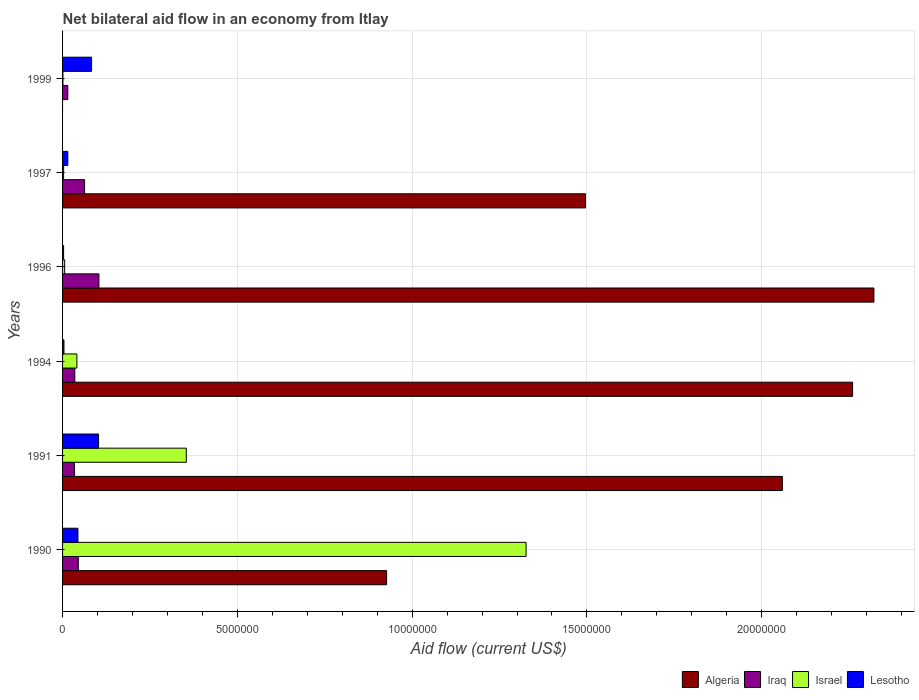How many groups of bars are there?
Your answer should be compact. 6. Are the number of bars per tick equal to the number of legend labels?
Keep it short and to the point. No. Are the number of bars on each tick of the Y-axis equal?
Ensure brevity in your answer.  No. How many bars are there on the 4th tick from the top?
Make the answer very short. 4. What is the label of the 5th group of bars from the top?
Your response must be concise. 1991. In how many cases, is the number of bars for a given year not equal to the number of legend labels?
Your response must be concise. 1. What is the net bilateral aid flow in Algeria in 1994?
Make the answer very short. 2.26e+07. Across all years, what is the maximum net bilateral aid flow in Israel?
Your answer should be very brief. 1.33e+07. Across all years, what is the minimum net bilateral aid flow in Algeria?
Keep it short and to the point. 0. What is the total net bilateral aid flow in Algeria in the graph?
Provide a succinct answer. 9.06e+07. What is the difference between the net bilateral aid flow in Iraq in 1991 and that in 1996?
Ensure brevity in your answer.  -7.00e+05. What is the average net bilateral aid flow in Algeria per year?
Your answer should be very brief. 1.51e+07. In the year 1999, what is the difference between the net bilateral aid flow in Israel and net bilateral aid flow in Lesotho?
Ensure brevity in your answer.  -8.20e+05. In how many years, is the net bilateral aid flow in Lesotho greater than 17000000 US$?
Make the answer very short. 0. What is the ratio of the net bilateral aid flow in Lesotho in 1994 to that in 1997?
Ensure brevity in your answer.  0.27. Is the difference between the net bilateral aid flow in Israel in 1990 and 1999 greater than the difference between the net bilateral aid flow in Lesotho in 1990 and 1999?
Ensure brevity in your answer.  Yes. What is the difference between the highest and the second highest net bilateral aid flow in Lesotho?
Provide a succinct answer. 2.00e+05. What is the difference between the highest and the lowest net bilateral aid flow in Israel?
Make the answer very short. 1.32e+07. In how many years, is the net bilateral aid flow in Algeria greater than the average net bilateral aid flow in Algeria taken over all years?
Offer a terse response. 3. Is it the case that in every year, the sum of the net bilateral aid flow in Lesotho and net bilateral aid flow in Israel is greater than the sum of net bilateral aid flow in Algeria and net bilateral aid flow in Iraq?
Offer a terse response. No. How many bars are there?
Provide a short and direct response. 23. How many years are there in the graph?
Keep it short and to the point. 6. Does the graph contain any zero values?
Offer a terse response. Yes. Where does the legend appear in the graph?
Give a very brief answer. Bottom right. How many legend labels are there?
Your answer should be compact. 4. What is the title of the graph?
Your answer should be very brief. Net bilateral aid flow in an economy from Itlay. What is the label or title of the X-axis?
Your response must be concise. Aid flow (current US$). What is the label or title of the Y-axis?
Provide a short and direct response. Years. What is the Aid flow (current US$) in Algeria in 1990?
Provide a short and direct response. 9.27e+06. What is the Aid flow (current US$) in Israel in 1990?
Your answer should be very brief. 1.33e+07. What is the Aid flow (current US$) in Algeria in 1991?
Provide a short and direct response. 2.06e+07. What is the Aid flow (current US$) in Israel in 1991?
Your answer should be very brief. 3.54e+06. What is the Aid flow (current US$) of Lesotho in 1991?
Provide a succinct answer. 1.03e+06. What is the Aid flow (current US$) of Algeria in 1994?
Your response must be concise. 2.26e+07. What is the Aid flow (current US$) of Iraq in 1994?
Offer a very short reply. 3.50e+05. What is the Aid flow (current US$) in Israel in 1994?
Keep it short and to the point. 4.10e+05. What is the Aid flow (current US$) in Lesotho in 1994?
Provide a succinct answer. 4.00e+04. What is the Aid flow (current US$) of Algeria in 1996?
Provide a succinct answer. 2.32e+07. What is the Aid flow (current US$) of Iraq in 1996?
Offer a very short reply. 1.04e+06. What is the Aid flow (current US$) in Israel in 1996?
Keep it short and to the point. 6.00e+04. What is the Aid flow (current US$) in Algeria in 1997?
Offer a very short reply. 1.50e+07. What is the Aid flow (current US$) of Iraq in 1997?
Ensure brevity in your answer.  6.30e+05. What is the Aid flow (current US$) in Israel in 1997?
Keep it short and to the point. 3.00e+04. What is the Aid flow (current US$) in Algeria in 1999?
Offer a terse response. 0. What is the Aid flow (current US$) of Lesotho in 1999?
Offer a terse response. 8.30e+05. Across all years, what is the maximum Aid flow (current US$) in Algeria?
Make the answer very short. 2.32e+07. Across all years, what is the maximum Aid flow (current US$) in Iraq?
Your answer should be very brief. 1.04e+06. Across all years, what is the maximum Aid flow (current US$) of Israel?
Give a very brief answer. 1.33e+07. Across all years, what is the maximum Aid flow (current US$) of Lesotho?
Your answer should be compact. 1.03e+06. Across all years, what is the minimum Aid flow (current US$) in Iraq?
Provide a short and direct response. 1.50e+05. Across all years, what is the minimum Aid flow (current US$) of Israel?
Make the answer very short. 10000. Across all years, what is the minimum Aid flow (current US$) in Lesotho?
Keep it short and to the point. 3.00e+04. What is the total Aid flow (current US$) in Algeria in the graph?
Make the answer very short. 9.06e+07. What is the total Aid flow (current US$) of Iraq in the graph?
Your answer should be very brief. 2.96e+06. What is the total Aid flow (current US$) in Israel in the graph?
Offer a terse response. 1.73e+07. What is the total Aid flow (current US$) of Lesotho in the graph?
Offer a terse response. 2.52e+06. What is the difference between the Aid flow (current US$) of Algeria in 1990 and that in 1991?
Keep it short and to the point. -1.13e+07. What is the difference between the Aid flow (current US$) of Israel in 1990 and that in 1991?
Give a very brief answer. 9.72e+06. What is the difference between the Aid flow (current US$) of Lesotho in 1990 and that in 1991?
Make the answer very short. -5.90e+05. What is the difference between the Aid flow (current US$) of Algeria in 1990 and that in 1994?
Make the answer very short. -1.33e+07. What is the difference between the Aid flow (current US$) of Iraq in 1990 and that in 1994?
Your answer should be very brief. 1.00e+05. What is the difference between the Aid flow (current US$) of Israel in 1990 and that in 1994?
Provide a short and direct response. 1.28e+07. What is the difference between the Aid flow (current US$) of Lesotho in 1990 and that in 1994?
Your answer should be very brief. 4.00e+05. What is the difference between the Aid flow (current US$) in Algeria in 1990 and that in 1996?
Offer a very short reply. -1.39e+07. What is the difference between the Aid flow (current US$) in Iraq in 1990 and that in 1996?
Your answer should be compact. -5.90e+05. What is the difference between the Aid flow (current US$) in Israel in 1990 and that in 1996?
Offer a terse response. 1.32e+07. What is the difference between the Aid flow (current US$) of Algeria in 1990 and that in 1997?
Provide a succinct answer. -5.69e+06. What is the difference between the Aid flow (current US$) of Israel in 1990 and that in 1997?
Offer a very short reply. 1.32e+07. What is the difference between the Aid flow (current US$) in Iraq in 1990 and that in 1999?
Keep it short and to the point. 3.00e+05. What is the difference between the Aid flow (current US$) of Israel in 1990 and that in 1999?
Ensure brevity in your answer.  1.32e+07. What is the difference between the Aid flow (current US$) of Lesotho in 1990 and that in 1999?
Make the answer very short. -3.90e+05. What is the difference between the Aid flow (current US$) in Algeria in 1991 and that in 1994?
Give a very brief answer. -2.01e+06. What is the difference between the Aid flow (current US$) of Israel in 1991 and that in 1994?
Make the answer very short. 3.13e+06. What is the difference between the Aid flow (current US$) of Lesotho in 1991 and that in 1994?
Your answer should be very brief. 9.90e+05. What is the difference between the Aid flow (current US$) in Algeria in 1991 and that in 1996?
Your answer should be compact. -2.62e+06. What is the difference between the Aid flow (current US$) in Iraq in 1991 and that in 1996?
Ensure brevity in your answer.  -7.00e+05. What is the difference between the Aid flow (current US$) in Israel in 1991 and that in 1996?
Your answer should be compact. 3.48e+06. What is the difference between the Aid flow (current US$) of Lesotho in 1991 and that in 1996?
Keep it short and to the point. 1.00e+06. What is the difference between the Aid flow (current US$) in Algeria in 1991 and that in 1997?
Offer a terse response. 5.63e+06. What is the difference between the Aid flow (current US$) in Iraq in 1991 and that in 1997?
Provide a succinct answer. -2.90e+05. What is the difference between the Aid flow (current US$) in Israel in 1991 and that in 1997?
Your answer should be very brief. 3.51e+06. What is the difference between the Aid flow (current US$) of Lesotho in 1991 and that in 1997?
Ensure brevity in your answer.  8.80e+05. What is the difference between the Aid flow (current US$) in Israel in 1991 and that in 1999?
Your answer should be compact. 3.53e+06. What is the difference between the Aid flow (current US$) of Lesotho in 1991 and that in 1999?
Give a very brief answer. 2.00e+05. What is the difference between the Aid flow (current US$) in Algeria in 1994 and that in 1996?
Provide a succinct answer. -6.10e+05. What is the difference between the Aid flow (current US$) in Iraq in 1994 and that in 1996?
Ensure brevity in your answer.  -6.90e+05. What is the difference between the Aid flow (current US$) of Israel in 1994 and that in 1996?
Provide a succinct answer. 3.50e+05. What is the difference between the Aid flow (current US$) of Algeria in 1994 and that in 1997?
Provide a short and direct response. 7.64e+06. What is the difference between the Aid flow (current US$) of Iraq in 1994 and that in 1997?
Ensure brevity in your answer.  -2.80e+05. What is the difference between the Aid flow (current US$) in Lesotho in 1994 and that in 1997?
Offer a very short reply. -1.10e+05. What is the difference between the Aid flow (current US$) of Israel in 1994 and that in 1999?
Ensure brevity in your answer.  4.00e+05. What is the difference between the Aid flow (current US$) of Lesotho in 1994 and that in 1999?
Give a very brief answer. -7.90e+05. What is the difference between the Aid flow (current US$) of Algeria in 1996 and that in 1997?
Offer a very short reply. 8.25e+06. What is the difference between the Aid flow (current US$) of Iraq in 1996 and that in 1997?
Provide a succinct answer. 4.10e+05. What is the difference between the Aid flow (current US$) of Israel in 1996 and that in 1997?
Provide a short and direct response. 3.00e+04. What is the difference between the Aid flow (current US$) in Lesotho in 1996 and that in 1997?
Offer a terse response. -1.20e+05. What is the difference between the Aid flow (current US$) of Iraq in 1996 and that in 1999?
Your answer should be very brief. 8.90e+05. What is the difference between the Aid flow (current US$) of Lesotho in 1996 and that in 1999?
Provide a short and direct response. -8.00e+05. What is the difference between the Aid flow (current US$) in Iraq in 1997 and that in 1999?
Make the answer very short. 4.80e+05. What is the difference between the Aid flow (current US$) of Israel in 1997 and that in 1999?
Ensure brevity in your answer.  2.00e+04. What is the difference between the Aid flow (current US$) in Lesotho in 1997 and that in 1999?
Keep it short and to the point. -6.80e+05. What is the difference between the Aid flow (current US$) in Algeria in 1990 and the Aid flow (current US$) in Iraq in 1991?
Provide a succinct answer. 8.93e+06. What is the difference between the Aid flow (current US$) in Algeria in 1990 and the Aid flow (current US$) in Israel in 1991?
Provide a succinct answer. 5.73e+06. What is the difference between the Aid flow (current US$) of Algeria in 1990 and the Aid flow (current US$) of Lesotho in 1991?
Ensure brevity in your answer.  8.24e+06. What is the difference between the Aid flow (current US$) of Iraq in 1990 and the Aid flow (current US$) of Israel in 1991?
Keep it short and to the point. -3.09e+06. What is the difference between the Aid flow (current US$) in Iraq in 1990 and the Aid flow (current US$) in Lesotho in 1991?
Ensure brevity in your answer.  -5.80e+05. What is the difference between the Aid flow (current US$) in Israel in 1990 and the Aid flow (current US$) in Lesotho in 1991?
Your answer should be compact. 1.22e+07. What is the difference between the Aid flow (current US$) of Algeria in 1990 and the Aid flow (current US$) of Iraq in 1994?
Offer a very short reply. 8.92e+06. What is the difference between the Aid flow (current US$) in Algeria in 1990 and the Aid flow (current US$) in Israel in 1994?
Provide a short and direct response. 8.86e+06. What is the difference between the Aid flow (current US$) in Algeria in 1990 and the Aid flow (current US$) in Lesotho in 1994?
Your response must be concise. 9.23e+06. What is the difference between the Aid flow (current US$) in Iraq in 1990 and the Aid flow (current US$) in Israel in 1994?
Ensure brevity in your answer.  4.00e+04. What is the difference between the Aid flow (current US$) of Israel in 1990 and the Aid flow (current US$) of Lesotho in 1994?
Ensure brevity in your answer.  1.32e+07. What is the difference between the Aid flow (current US$) of Algeria in 1990 and the Aid flow (current US$) of Iraq in 1996?
Provide a short and direct response. 8.23e+06. What is the difference between the Aid flow (current US$) in Algeria in 1990 and the Aid flow (current US$) in Israel in 1996?
Provide a succinct answer. 9.21e+06. What is the difference between the Aid flow (current US$) in Algeria in 1990 and the Aid flow (current US$) in Lesotho in 1996?
Your answer should be compact. 9.24e+06. What is the difference between the Aid flow (current US$) of Iraq in 1990 and the Aid flow (current US$) of Lesotho in 1996?
Provide a succinct answer. 4.20e+05. What is the difference between the Aid flow (current US$) in Israel in 1990 and the Aid flow (current US$) in Lesotho in 1996?
Your response must be concise. 1.32e+07. What is the difference between the Aid flow (current US$) of Algeria in 1990 and the Aid flow (current US$) of Iraq in 1997?
Your response must be concise. 8.64e+06. What is the difference between the Aid flow (current US$) in Algeria in 1990 and the Aid flow (current US$) in Israel in 1997?
Offer a very short reply. 9.24e+06. What is the difference between the Aid flow (current US$) of Algeria in 1990 and the Aid flow (current US$) of Lesotho in 1997?
Offer a very short reply. 9.12e+06. What is the difference between the Aid flow (current US$) in Iraq in 1990 and the Aid flow (current US$) in Israel in 1997?
Your answer should be very brief. 4.20e+05. What is the difference between the Aid flow (current US$) in Israel in 1990 and the Aid flow (current US$) in Lesotho in 1997?
Your answer should be compact. 1.31e+07. What is the difference between the Aid flow (current US$) of Algeria in 1990 and the Aid flow (current US$) of Iraq in 1999?
Provide a short and direct response. 9.12e+06. What is the difference between the Aid flow (current US$) of Algeria in 1990 and the Aid flow (current US$) of Israel in 1999?
Offer a very short reply. 9.26e+06. What is the difference between the Aid flow (current US$) of Algeria in 1990 and the Aid flow (current US$) of Lesotho in 1999?
Offer a very short reply. 8.44e+06. What is the difference between the Aid flow (current US$) of Iraq in 1990 and the Aid flow (current US$) of Israel in 1999?
Give a very brief answer. 4.40e+05. What is the difference between the Aid flow (current US$) of Iraq in 1990 and the Aid flow (current US$) of Lesotho in 1999?
Offer a very short reply. -3.80e+05. What is the difference between the Aid flow (current US$) of Israel in 1990 and the Aid flow (current US$) of Lesotho in 1999?
Ensure brevity in your answer.  1.24e+07. What is the difference between the Aid flow (current US$) in Algeria in 1991 and the Aid flow (current US$) in Iraq in 1994?
Keep it short and to the point. 2.02e+07. What is the difference between the Aid flow (current US$) of Algeria in 1991 and the Aid flow (current US$) of Israel in 1994?
Keep it short and to the point. 2.02e+07. What is the difference between the Aid flow (current US$) in Algeria in 1991 and the Aid flow (current US$) in Lesotho in 1994?
Provide a succinct answer. 2.06e+07. What is the difference between the Aid flow (current US$) in Iraq in 1991 and the Aid flow (current US$) in Israel in 1994?
Offer a very short reply. -7.00e+04. What is the difference between the Aid flow (current US$) of Iraq in 1991 and the Aid flow (current US$) of Lesotho in 1994?
Offer a very short reply. 3.00e+05. What is the difference between the Aid flow (current US$) in Israel in 1991 and the Aid flow (current US$) in Lesotho in 1994?
Offer a very short reply. 3.50e+06. What is the difference between the Aid flow (current US$) of Algeria in 1991 and the Aid flow (current US$) of Iraq in 1996?
Keep it short and to the point. 1.96e+07. What is the difference between the Aid flow (current US$) in Algeria in 1991 and the Aid flow (current US$) in Israel in 1996?
Your answer should be very brief. 2.05e+07. What is the difference between the Aid flow (current US$) in Algeria in 1991 and the Aid flow (current US$) in Lesotho in 1996?
Make the answer very short. 2.06e+07. What is the difference between the Aid flow (current US$) in Israel in 1991 and the Aid flow (current US$) in Lesotho in 1996?
Offer a very short reply. 3.51e+06. What is the difference between the Aid flow (current US$) of Algeria in 1991 and the Aid flow (current US$) of Iraq in 1997?
Ensure brevity in your answer.  2.00e+07. What is the difference between the Aid flow (current US$) of Algeria in 1991 and the Aid flow (current US$) of Israel in 1997?
Your response must be concise. 2.06e+07. What is the difference between the Aid flow (current US$) of Algeria in 1991 and the Aid flow (current US$) of Lesotho in 1997?
Your response must be concise. 2.04e+07. What is the difference between the Aid flow (current US$) in Iraq in 1991 and the Aid flow (current US$) in Israel in 1997?
Provide a short and direct response. 3.10e+05. What is the difference between the Aid flow (current US$) of Iraq in 1991 and the Aid flow (current US$) of Lesotho in 1997?
Offer a terse response. 1.90e+05. What is the difference between the Aid flow (current US$) of Israel in 1991 and the Aid flow (current US$) of Lesotho in 1997?
Ensure brevity in your answer.  3.39e+06. What is the difference between the Aid flow (current US$) of Algeria in 1991 and the Aid flow (current US$) of Iraq in 1999?
Provide a succinct answer. 2.04e+07. What is the difference between the Aid flow (current US$) of Algeria in 1991 and the Aid flow (current US$) of Israel in 1999?
Make the answer very short. 2.06e+07. What is the difference between the Aid flow (current US$) of Algeria in 1991 and the Aid flow (current US$) of Lesotho in 1999?
Make the answer very short. 1.98e+07. What is the difference between the Aid flow (current US$) of Iraq in 1991 and the Aid flow (current US$) of Lesotho in 1999?
Provide a short and direct response. -4.90e+05. What is the difference between the Aid flow (current US$) in Israel in 1991 and the Aid flow (current US$) in Lesotho in 1999?
Provide a short and direct response. 2.71e+06. What is the difference between the Aid flow (current US$) in Algeria in 1994 and the Aid flow (current US$) in Iraq in 1996?
Give a very brief answer. 2.16e+07. What is the difference between the Aid flow (current US$) in Algeria in 1994 and the Aid flow (current US$) in Israel in 1996?
Your answer should be very brief. 2.25e+07. What is the difference between the Aid flow (current US$) in Algeria in 1994 and the Aid flow (current US$) in Lesotho in 1996?
Your response must be concise. 2.26e+07. What is the difference between the Aid flow (current US$) in Iraq in 1994 and the Aid flow (current US$) in Israel in 1996?
Provide a succinct answer. 2.90e+05. What is the difference between the Aid flow (current US$) in Algeria in 1994 and the Aid flow (current US$) in Iraq in 1997?
Keep it short and to the point. 2.20e+07. What is the difference between the Aid flow (current US$) of Algeria in 1994 and the Aid flow (current US$) of Israel in 1997?
Your answer should be very brief. 2.26e+07. What is the difference between the Aid flow (current US$) of Algeria in 1994 and the Aid flow (current US$) of Lesotho in 1997?
Provide a succinct answer. 2.24e+07. What is the difference between the Aid flow (current US$) of Iraq in 1994 and the Aid flow (current US$) of Israel in 1997?
Your answer should be very brief. 3.20e+05. What is the difference between the Aid flow (current US$) of Algeria in 1994 and the Aid flow (current US$) of Iraq in 1999?
Offer a very short reply. 2.24e+07. What is the difference between the Aid flow (current US$) in Algeria in 1994 and the Aid flow (current US$) in Israel in 1999?
Ensure brevity in your answer.  2.26e+07. What is the difference between the Aid flow (current US$) of Algeria in 1994 and the Aid flow (current US$) of Lesotho in 1999?
Give a very brief answer. 2.18e+07. What is the difference between the Aid flow (current US$) of Iraq in 1994 and the Aid flow (current US$) of Israel in 1999?
Keep it short and to the point. 3.40e+05. What is the difference between the Aid flow (current US$) of Iraq in 1994 and the Aid flow (current US$) of Lesotho in 1999?
Make the answer very short. -4.80e+05. What is the difference between the Aid flow (current US$) of Israel in 1994 and the Aid flow (current US$) of Lesotho in 1999?
Ensure brevity in your answer.  -4.20e+05. What is the difference between the Aid flow (current US$) in Algeria in 1996 and the Aid flow (current US$) in Iraq in 1997?
Give a very brief answer. 2.26e+07. What is the difference between the Aid flow (current US$) in Algeria in 1996 and the Aid flow (current US$) in Israel in 1997?
Give a very brief answer. 2.32e+07. What is the difference between the Aid flow (current US$) in Algeria in 1996 and the Aid flow (current US$) in Lesotho in 1997?
Keep it short and to the point. 2.31e+07. What is the difference between the Aid flow (current US$) of Iraq in 1996 and the Aid flow (current US$) of Israel in 1997?
Keep it short and to the point. 1.01e+06. What is the difference between the Aid flow (current US$) of Iraq in 1996 and the Aid flow (current US$) of Lesotho in 1997?
Keep it short and to the point. 8.90e+05. What is the difference between the Aid flow (current US$) of Israel in 1996 and the Aid flow (current US$) of Lesotho in 1997?
Make the answer very short. -9.00e+04. What is the difference between the Aid flow (current US$) in Algeria in 1996 and the Aid flow (current US$) in Iraq in 1999?
Your answer should be compact. 2.31e+07. What is the difference between the Aid flow (current US$) in Algeria in 1996 and the Aid flow (current US$) in Israel in 1999?
Keep it short and to the point. 2.32e+07. What is the difference between the Aid flow (current US$) in Algeria in 1996 and the Aid flow (current US$) in Lesotho in 1999?
Ensure brevity in your answer.  2.24e+07. What is the difference between the Aid flow (current US$) of Iraq in 1996 and the Aid flow (current US$) of Israel in 1999?
Provide a short and direct response. 1.03e+06. What is the difference between the Aid flow (current US$) of Iraq in 1996 and the Aid flow (current US$) of Lesotho in 1999?
Ensure brevity in your answer.  2.10e+05. What is the difference between the Aid flow (current US$) in Israel in 1996 and the Aid flow (current US$) in Lesotho in 1999?
Provide a succinct answer. -7.70e+05. What is the difference between the Aid flow (current US$) in Algeria in 1997 and the Aid flow (current US$) in Iraq in 1999?
Your answer should be compact. 1.48e+07. What is the difference between the Aid flow (current US$) in Algeria in 1997 and the Aid flow (current US$) in Israel in 1999?
Offer a very short reply. 1.50e+07. What is the difference between the Aid flow (current US$) of Algeria in 1997 and the Aid flow (current US$) of Lesotho in 1999?
Ensure brevity in your answer.  1.41e+07. What is the difference between the Aid flow (current US$) of Iraq in 1997 and the Aid flow (current US$) of Israel in 1999?
Make the answer very short. 6.20e+05. What is the difference between the Aid flow (current US$) of Iraq in 1997 and the Aid flow (current US$) of Lesotho in 1999?
Your answer should be compact. -2.00e+05. What is the difference between the Aid flow (current US$) of Israel in 1997 and the Aid flow (current US$) of Lesotho in 1999?
Ensure brevity in your answer.  -8.00e+05. What is the average Aid flow (current US$) in Algeria per year?
Offer a terse response. 1.51e+07. What is the average Aid flow (current US$) in Iraq per year?
Your answer should be very brief. 4.93e+05. What is the average Aid flow (current US$) of Israel per year?
Offer a terse response. 2.88e+06. In the year 1990, what is the difference between the Aid flow (current US$) of Algeria and Aid flow (current US$) of Iraq?
Make the answer very short. 8.82e+06. In the year 1990, what is the difference between the Aid flow (current US$) of Algeria and Aid flow (current US$) of Israel?
Offer a terse response. -3.99e+06. In the year 1990, what is the difference between the Aid flow (current US$) of Algeria and Aid flow (current US$) of Lesotho?
Provide a short and direct response. 8.83e+06. In the year 1990, what is the difference between the Aid flow (current US$) in Iraq and Aid flow (current US$) in Israel?
Your response must be concise. -1.28e+07. In the year 1990, what is the difference between the Aid flow (current US$) in Israel and Aid flow (current US$) in Lesotho?
Your answer should be compact. 1.28e+07. In the year 1991, what is the difference between the Aid flow (current US$) of Algeria and Aid flow (current US$) of Iraq?
Your answer should be compact. 2.02e+07. In the year 1991, what is the difference between the Aid flow (current US$) in Algeria and Aid flow (current US$) in Israel?
Provide a succinct answer. 1.70e+07. In the year 1991, what is the difference between the Aid flow (current US$) in Algeria and Aid flow (current US$) in Lesotho?
Keep it short and to the point. 1.96e+07. In the year 1991, what is the difference between the Aid flow (current US$) in Iraq and Aid flow (current US$) in Israel?
Keep it short and to the point. -3.20e+06. In the year 1991, what is the difference between the Aid flow (current US$) of Iraq and Aid flow (current US$) of Lesotho?
Your answer should be very brief. -6.90e+05. In the year 1991, what is the difference between the Aid flow (current US$) in Israel and Aid flow (current US$) in Lesotho?
Your answer should be compact. 2.51e+06. In the year 1994, what is the difference between the Aid flow (current US$) in Algeria and Aid flow (current US$) in Iraq?
Ensure brevity in your answer.  2.22e+07. In the year 1994, what is the difference between the Aid flow (current US$) in Algeria and Aid flow (current US$) in Israel?
Offer a very short reply. 2.22e+07. In the year 1994, what is the difference between the Aid flow (current US$) of Algeria and Aid flow (current US$) of Lesotho?
Your answer should be very brief. 2.26e+07. In the year 1994, what is the difference between the Aid flow (current US$) of Israel and Aid flow (current US$) of Lesotho?
Provide a short and direct response. 3.70e+05. In the year 1996, what is the difference between the Aid flow (current US$) of Algeria and Aid flow (current US$) of Iraq?
Your answer should be compact. 2.22e+07. In the year 1996, what is the difference between the Aid flow (current US$) in Algeria and Aid flow (current US$) in Israel?
Ensure brevity in your answer.  2.32e+07. In the year 1996, what is the difference between the Aid flow (current US$) of Algeria and Aid flow (current US$) of Lesotho?
Give a very brief answer. 2.32e+07. In the year 1996, what is the difference between the Aid flow (current US$) of Iraq and Aid flow (current US$) of Israel?
Your answer should be compact. 9.80e+05. In the year 1996, what is the difference between the Aid flow (current US$) in Iraq and Aid flow (current US$) in Lesotho?
Provide a succinct answer. 1.01e+06. In the year 1997, what is the difference between the Aid flow (current US$) in Algeria and Aid flow (current US$) in Iraq?
Offer a very short reply. 1.43e+07. In the year 1997, what is the difference between the Aid flow (current US$) in Algeria and Aid flow (current US$) in Israel?
Offer a very short reply. 1.49e+07. In the year 1997, what is the difference between the Aid flow (current US$) in Algeria and Aid flow (current US$) in Lesotho?
Keep it short and to the point. 1.48e+07. In the year 1997, what is the difference between the Aid flow (current US$) of Iraq and Aid flow (current US$) of Israel?
Keep it short and to the point. 6.00e+05. In the year 1997, what is the difference between the Aid flow (current US$) of Iraq and Aid flow (current US$) of Lesotho?
Make the answer very short. 4.80e+05. In the year 1999, what is the difference between the Aid flow (current US$) of Iraq and Aid flow (current US$) of Israel?
Provide a succinct answer. 1.40e+05. In the year 1999, what is the difference between the Aid flow (current US$) in Iraq and Aid flow (current US$) in Lesotho?
Offer a terse response. -6.80e+05. In the year 1999, what is the difference between the Aid flow (current US$) in Israel and Aid flow (current US$) in Lesotho?
Keep it short and to the point. -8.20e+05. What is the ratio of the Aid flow (current US$) of Algeria in 1990 to that in 1991?
Offer a terse response. 0.45. What is the ratio of the Aid flow (current US$) of Iraq in 1990 to that in 1991?
Keep it short and to the point. 1.32. What is the ratio of the Aid flow (current US$) of Israel in 1990 to that in 1991?
Your response must be concise. 3.75. What is the ratio of the Aid flow (current US$) in Lesotho in 1990 to that in 1991?
Keep it short and to the point. 0.43. What is the ratio of the Aid flow (current US$) in Algeria in 1990 to that in 1994?
Provide a short and direct response. 0.41. What is the ratio of the Aid flow (current US$) of Iraq in 1990 to that in 1994?
Offer a very short reply. 1.29. What is the ratio of the Aid flow (current US$) in Israel in 1990 to that in 1994?
Your answer should be compact. 32.34. What is the ratio of the Aid flow (current US$) of Lesotho in 1990 to that in 1994?
Offer a very short reply. 11. What is the ratio of the Aid flow (current US$) in Algeria in 1990 to that in 1996?
Your answer should be compact. 0.4. What is the ratio of the Aid flow (current US$) of Iraq in 1990 to that in 1996?
Provide a short and direct response. 0.43. What is the ratio of the Aid flow (current US$) in Israel in 1990 to that in 1996?
Keep it short and to the point. 221. What is the ratio of the Aid flow (current US$) of Lesotho in 1990 to that in 1996?
Ensure brevity in your answer.  14.67. What is the ratio of the Aid flow (current US$) of Algeria in 1990 to that in 1997?
Give a very brief answer. 0.62. What is the ratio of the Aid flow (current US$) of Israel in 1990 to that in 1997?
Make the answer very short. 442. What is the ratio of the Aid flow (current US$) of Lesotho in 1990 to that in 1997?
Your answer should be very brief. 2.93. What is the ratio of the Aid flow (current US$) of Iraq in 1990 to that in 1999?
Give a very brief answer. 3. What is the ratio of the Aid flow (current US$) in Israel in 1990 to that in 1999?
Offer a very short reply. 1326. What is the ratio of the Aid flow (current US$) of Lesotho in 1990 to that in 1999?
Your answer should be compact. 0.53. What is the ratio of the Aid flow (current US$) of Algeria in 1991 to that in 1994?
Make the answer very short. 0.91. What is the ratio of the Aid flow (current US$) in Iraq in 1991 to that in 1994?
Give a very brief answer. 0.97. What is the ratio of the Aid flow (current US$) of Israel in 1991 to that in 1994?
Your response must be concise. 8.63. What is the ratio of the Aid flow (current US$) in Lesotho in 1991 to that in 1994?
Provide a succinct answer. 25.75. What is the ratio of the Aid flow (current US$) of Algeria in 1991 to that in 1996?
Offer a terse response. 0.89. What is the ratio of the Aid flow (current US$) of Iraq in 1991 to that in 1996?
Your answer should be compact. 0.33. What is the ratio of the Aid flow (current US$) in Lesotho in 1991 to that in 1996?
Your answer should be compact. 34.33. What is the ratio of the Aid flow (current US$) in Algeria in 1991 to that in 1997?
Offer a very short reply. 1.38. What is the ratio of the Aid flow (current US$) in Iraq in 1991 to that in 1997?
Give a very brief answer. 0.54. What is the ratio of the Aid flow (current US$) of Israel in 1991 to that in 1997?
Your answer should be compact. 118. What is the ratio of the Aid flow (current US$) of Lesotho in 1991 to that in 1997?
Your response must be concise. 6.87. What is the ratio of the Aid flow (current US$) of Iraq in 1991 to that in 1999?
Your answer should be compact. 2.27. What is the ratio of the Aid flow (current US$) of Israel in 1991 to that in 1999?
Your response must be concise. 354. What is the ratio of the Aid flow (current US$) of Lesotho in 1991 to that in 1999?
Your answer should be compact. 1.24. What is the ratio of the Aid flow (current US$) in Algeria in 1994 to that in 1996?
Provide a succinct answer. 0.97. What is the ratio of the Aid flow (current US$) of Iraq in 1994 to that in 1996?
Provide a succinct answer. 0.34. What is the ratio of the Aid flow (current US$) in Israel in 1994 to that in 1996?
Keep it short and to the point. 6.83. What is the ratio of the Aid flow (current US$) in Lesotho in 1994 to that in 1996?
Offer a terse response. 1.33. What is the ratio of the Aid flow (current US$) in Algeria in 1994 to that in 1997?
Your answer should be very brief. 1.51. What is the ratio of the Aid flow (current US$) of Iraq in 1994 to that in 1997?
Keep it short and to the point. 0.56. What is the ratio of the Aid flow (current US$) in Israel in 1994 to that in 1997?
Give a very brief answer. 13.67. What is the ratio of the Aid flow (current US$) in Lesotho in 1994 to that in 1997?
Provide a succinct answer. 0.27. What is the ratio of the Aid flow (current US$) in Iraq in 1994 to that in 1999?
Your answer should be compact. 2.33. What is the ratio of the Aid flow (current US$) of Israel in 1994 to that in 1999?
Offer a very short reply. 41. What is the ratio of the Aid flow (current US$) in Lesotho in 1994 to that in 1999?
Your answer should be compact. 0.05. What is the ratio of the Aid flow (current US$) in Algeria in 1996 to that in 1997?
Ensure brevity in your answer.  1.55. What is the ratio of the Aid flow (current US$) of Iraq in 1996 to that in 1997?
Ensure brevity in your answer.  1.65. What is the ratio of the Aid flow (current US$) in Iraq in 1996 to that in 1999?
Your response must be concise. 6.93. What is the ratio of the Aid flow (current US$) of Lesotho in 1996 to that in 1999?
Make the answer very short. 0.04. What is the ratio of the Aid flow (current US$) of Iraq in 1997 to that in 1999?
Keep it short and to the point. 4.2. What is the ratio of the Aid flow (current US$) in Israel in 1997 to that in 1999?
Provide a short and direct response. 3. What is the ratio of the Aid flow (current US$) of Lesotho in 1997 to that in 1999?
Offer a terse response. 0.18. What is the difference between the highest and the second highest Aid flow (current US$) in Israel?
Ensure brevity in your answer.  9.72e+06. What is the difference between the highest and the second highest Aid flow (current US$) of Lesotho?
Make the answer very short. 2.00e+05. What is the difference between the highest and the lowest Aid flow (current US$) of Algeria?
Give a very brief answer. 2.32e+07. What is the difference between the highest and the lowest Aid flow (current US$) in Iraq?
Provide a short and direct response. 8.90e+05. What is the difference between the highest and the lowest Aid flow (current US$) in Israel?
Your response must be concise. 1.32e+07. What is the difference between the highest and the lowest Aid flow (current US$) in Lesotho?
Your response must be concise. 1.00e+06. 